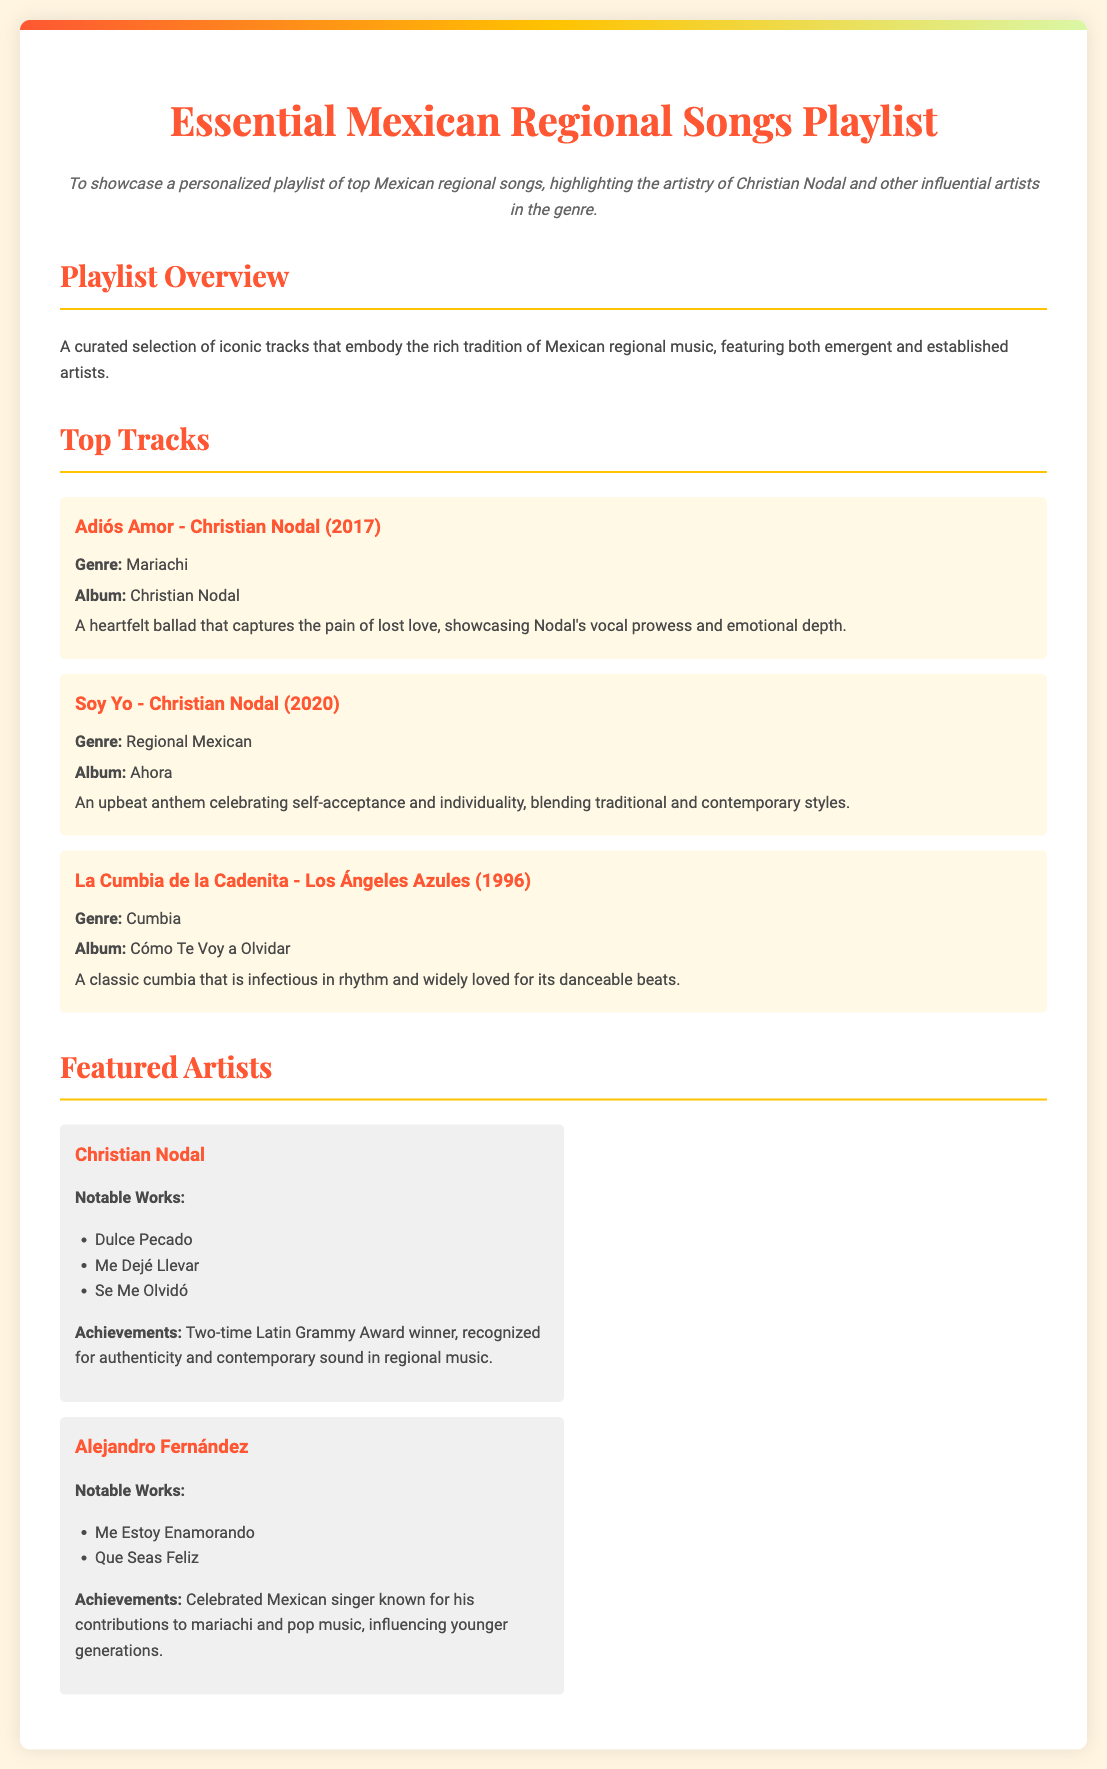What is the title of the playlist? The title is provided at the top of the document under the main heading.
Answer: Essential Mexican Regional Songs Playlist Who is the featured artist that has won two Latin Grammy Awards? The artist is mentioned in the featured artists section with their achievements.
Answer: Christian Nodal What year was "Adiós Amor" released? The release year is included in the song details of the top tracks.
Answer: 2017 What genre is the song "La Cumbia de la Cadenita"? The genre is specified in the song's information in the top tracks section.
Answer: Cumbia Which song promotes self-acceptance and individuality? The description for the song outlines its themes.
Answer: Soy Yo What notable work is associated with Alejandro Fernández? This track is listed under his notable works in the featured artists section.
Answer: Me Estoy Enamorando How many featured artists are listed in the document? The number of artists can be counted in the featured artists section.
Answer: 2 What is the main objective stated in the document? The objective is clearly articulated in a dedicated section.
Answer: To showcase a personalized playlist of top Mexican regional songs What is the background color of the document? The color is specified in the styling section of the document.
Answer: #FFF5E1 